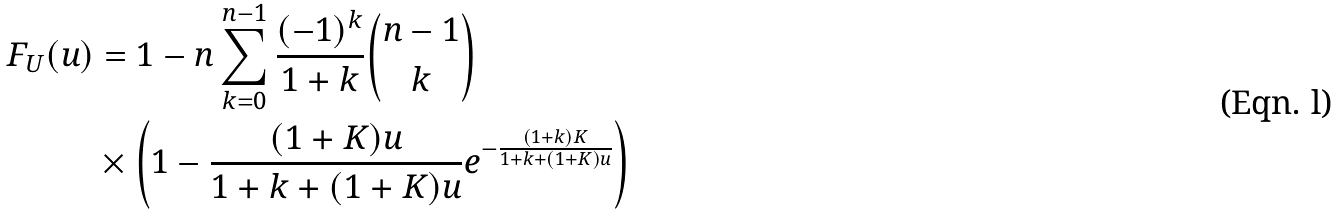<formula> <loc_0><loc_0><loc_500><loc_500>F _ { U } ( u ) & = 1 - n \sum ^ { n - 1 } _ { k = 0 } \frac { ( - 1 ) ^ { k } } { 1 + k } \binom { n - 1 } { k } \\ & \times \left ( 1 - \frac { ( 1 + K ) u } { 1 + k + ( 1 + K ) u } e ^ { - \frac { ( 1 + k ) K } { 1 + k + ( 1 + K ) u } } \right )</formula> 